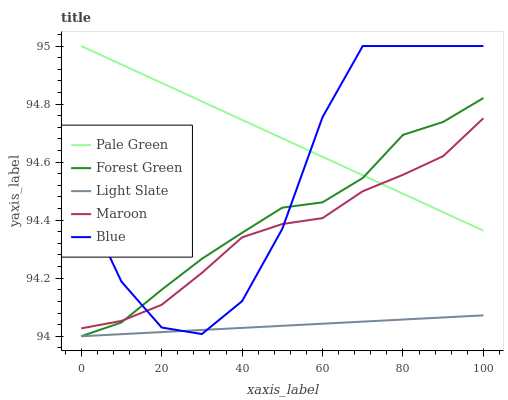Does Light Slate have the minimum area under the curve?
Answer yes or no. Yes. Does Pale Green have the maximum area under the curve?
Answer yes or no. Yes. Does Blue have the minimum area under the curve?
Answer yes or no. No. Does Blue have the maximum area under the curve?
Answer yes or no. No. Is Light Slate the smoothest?
Answer yes or no. Yes. Is Blue the roughest?
Answer yes or no. Yes. Is Forest Green the smoothest?
Answer yes or no. No. Is Forest Green the roughest?
Answer yes or no. No. Does Blue have the lowest value?
Answer yes or no. No. Does Pale Green have the highest value?
Answer yes or no. Yes. Does Forest Green have the highest value?
Answer yes or no. No. Is Light Slate less than Pale Green?
Answer yes or no. Yes. Is Maroon greater than Light Slate?
Answer yes or no. Yes. Does Light Slate intersect Forest Green?
Answer yes or no. Yes. Is Light Slate less than Forest Green?
Answer yes or no. No. Is Light Slate greater than Forest Green?
Answer yes or no. No. Does Light Slate intersect Pale Green?
Answer yes or no. No. 